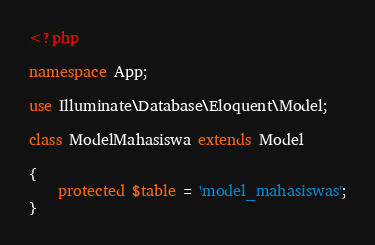<code> <loc_0><loc_0><loc_500><loc_500><_PHP_><?php

namespace App;

use Illuminate\Database\Eloquent\Model;

class ModelMahasiswa extends Model

{
    protected $table = 'model_mahasiswas';
}
</code> 